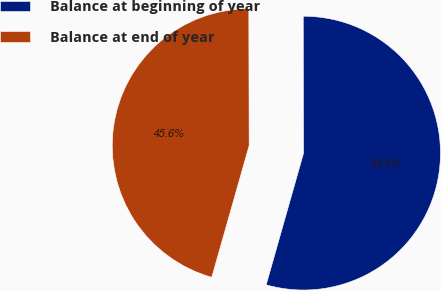Convert chart. <chart><loc_0><loc_0><loc_500><loc_500><pie_chart><fcel>Balance at beginning of year<fcel>Balance at end of year<nl><fcel>54.44%<fcel>45.56%<nl></chart> 